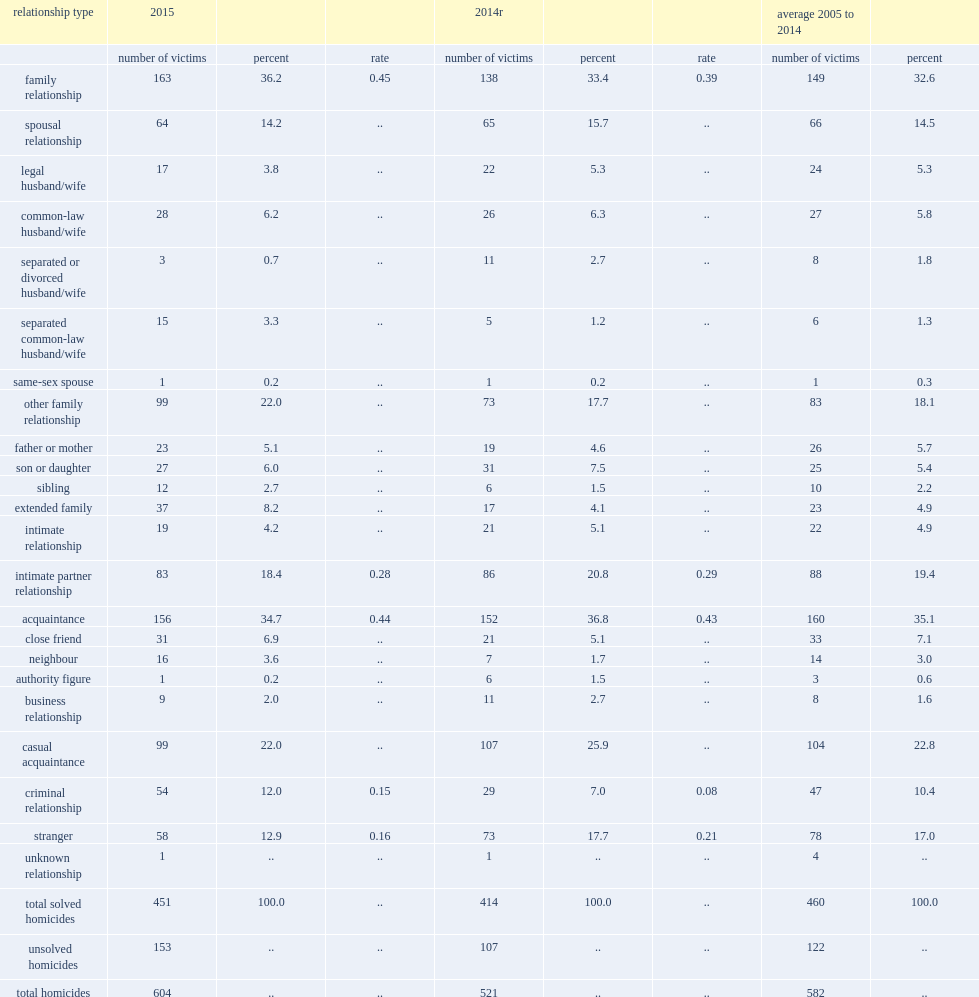What was the number of victims killed by a stranger in 2015? 58.0. What was the number of homicides committed by a person with whom the victim had a criminal relationship in 2015? 54.0. What was the number of intimate partner homicides reported in canada in 2015? 83.0. What was the rate of intimate partner homicides reported in 2015? 0.28. 